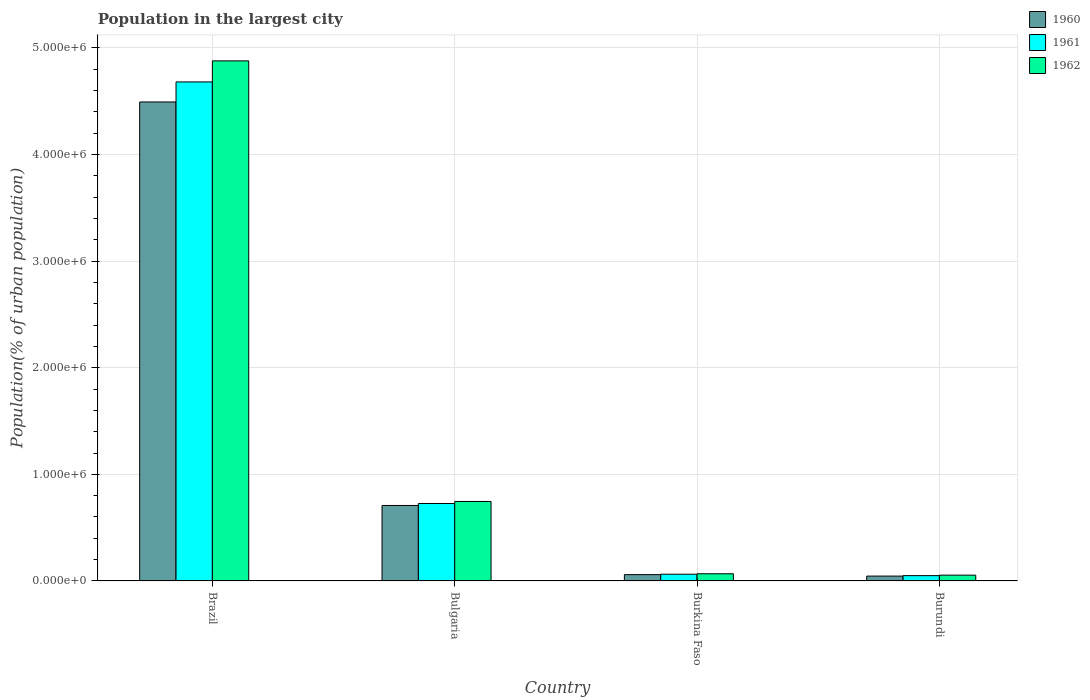How many different coloured bars are there?
Provide a short and direct response. 3. Are the number of bars per tick equal to the number of legend labels?
Your answer should be very brief. Yes. Are the number of bars on each tick of the X-axis equal?
Offer a terse response. Yes. How many bars are there on the 2nd tick from the left?
Offer a terse response. 3. What is the label of the 4th group of bars from the left?
Offer a very short reply. Burundi. What is the population in the largest city in 1960 in Brazil?
Provide a succinct answer. 4.49e+06. Across all countries, what is the maximum population in the largest city in 1961?
Provide a short and direct response. 4.68e+06. Across all countries, what is the minimum population in the largest city in 1962?
Offer a terse response. 5.44e+04. In which country was the population in the largest city in 1961 maximum?
Offer a terse response. Brazil. In which country was the population in the largest city in 1962 minimum?
Make the answer very short. Burundi. What is the total population in the largest city in 1960 in the graph?
Provide a succinct answer. 5.31e+06. What is the difference between the population in the largest city in 1962 in Bulgaria and that in Burundi?
Keep it short and to the point. 6.91e+05. What is the difference between the population in the largest city in 1960 in Burkina Faso and the population in the largest city in 1961 in Burundi?
Offer a very short reply. 9358. What is the average population in the largest city in 1960 per country?
Ensure brevity in your answer.  1.33e+06. What is the difference between the population in the largest city of/in 1962 and population in the largest city of/in 1961 in Burundi?
Provide a short and direct response. 4599. In how many countries, is the population in the largest city in 1960 greater than 600000 %?
Your answer should be very brief. 2. What is the ratio of the population in the largest city in 1961 in Brazil to that in Bulgaria?
Give a very brief answer. 6.44. Is the difference between the population in the largest city in 1962 in Brazil and Bulgaria greater than the difference between the population in the largest city in 1961 in Brazil and Bulgaria?
Keep it short and to the point. Yes. What is the difference between the highest and the second highest population in the largest city in 1961?
Your answer should be compact. -6.63e+05. What is the difference between the highest and the lowest population in the largest city in 1960?
Give a very brief answer. 4.45e+06. In how many countries, is the population in the largest city in 1961 greater than the average population in the largest city in 1961 taken over all countries?
Ensure brevity in your answer.  1. What does the 1st bar from the left in Brazil represents?
Your answer should be compact. 1960. How many bars are there?
Keep it short and to the point. 12. What is the difference between two consecutive major ticks on the Y-axis?
Give a very brief answer. 1.00e+06. Does the graph contain grids?
Your answer should be compact. Yes. How many legend labels are there?
Your answer should be compact. 3. What is the title of the graph?
Ensure brevity in your answer.  Population in the largest city. Does "1996" appear as one of the legend labels in the graph?
Ensure brevity in your answer.  No. What is the label or title of the X-axis?
Make the answer very short. Country. What is the label or title of the Y-axis?
Your response must be concise. Population(% of urban population). What is the Population(% of urban population) of 1960 in Brazil?
Offer a very short reply. 4.49e+06. What is the Population(% of urban population) of 1961 in Brazil?
Ensure brevity in your answer.  4.68e+06. What is the Population(% of urban population) in 1962 in Brazil?
Your response must be concise. 4.88e+06. What is the Population(% of urban population) of 1960 in Bulgaria?
Keep it short and to the point. 7.08e+05. What is the Population(% of urban population) in 1961 in Bulgaria?
Ensure brevity in your answer.  7.27e+05. What is the Population(% of urban population) of 1962 in Bulgaria?
Make the answer very short. 7.46e+05. What is the Population(% of urban population) in 1960 in Burkina Faso?
Provide a short and direct response. 5.91e+04. What is the Population(% of urban population) of 1961 in Burkina Faso?
Ensure brevity in your answer.  6.31e+04. What is the Population(% of urban population) in 1962 in Burkina Faso?
Your answer should be very brief. 6.73e+04. What is the Population(% of urban population) in 1960 in Burundi?
Make the answer very short. 4.56e+04. What is the Population(% of urban population) in 1961 in Burundi?
Offer a very short reply. 4.98e+04. What is the Population(% of urban population) of 1962 in Burundi?
Provide a short and direct response. 5.44e+04. Across all countries, what is the maximum Population(% of urban population) of 1960?
Ensure brevity in your answer.  4.49e+06. Across all countries, what is the maximum Population(% of urban population) in 1961?
Your answer should be compact. 4.68e+06. Across all countries, what is the maximum Population(% of urban population) of 1962?
Make the answer very short. 4.88e+06. Across all countries, what is the minimum Population(% of urban population) in 1960?
Keep it short and to the point. 4.56e+04. Across all countries, what is the minimum Population(% of urban population) in 1961?
Your answer should be compact. 4.98e+04. Across all countries, what is the minimum Population(% of urban population) in 1962?
Ensure brevity in your answer.  5.44e+04. What is the total Population(% of urban population) of 1960 in the graph?
Offer a terse response. 5.31e+06. What is the total Population(% of urban population) in 1961 in the graph?
Make the answer very short. 5.52e+06. What is the total Population(% of urban population) of 1962 in the graph?
Ensure brevity in your answer.  5.75e+06. What is the difference between the Population(% of urban population) in 1960 in Brazil and that in Bulgaria?
Your answer should be compact. 3.79e+06. What is the difference between the Population(% of urban population) in 1961 in Brazil and that in Bulgaria?
Give a very brief answer. 3.95e+06. What is the difference between the Population(% of urban population) in 1962 in Brazil and that in Bulgaria?
Provide a short and direct response. 4.13e+06. What is the difference between the Population(% of urban population) of 1960 in Brazil and that in Burkina Faso?
Your answer should be compact. 4.43e+06. What is the difference between the Population(% of urban population) of 1961 in Brazil and that in Burkina Faso?
Offer a very short reply. 4.62e+06. What is the difference between the Population(% of urban population) of 1962 in Brazil and that in Burkina Faso?
Your response must be concise. 4.81e+06. What is the difference between the Population(% of urban population) in 1960 in Brazil and that in Burundi?
Keep it short and to the point. 4.45e+06. What is the difference between the Population(% of urban population) of 1961 in Brazil and that in Burundi?
Ensure brevity in your answer.  4.63e+06. What is the difference between the Population(% of urban population) of 1962 in Brazil and that in Burundi?
Ensure brevity in your answer.  4.82e+06. What is the difference between the Population(% of urban population) of 1960 in Bulgaria and that in Burkina Faso?
Keep it short and to the point. 6.49e+05. What is the difference between the Population(% of urban population) of 1961 in Bulgaria and that in Burkina Faso?
Offer a terse response. 6.63e+05. What is the difference between the Population(% of urban population) in 1962 in Bulgaria and that in Burkina Faso?
Provide a short and direct response. 6.78e+05. What is the difference between the Population(% of urban population) of 1960 in Bulgaria and that in Burundi?
Your response must be concise. 6.62e+05. What is the difference between the Population(% of urban population) in 1961 in Bulgaria and that in Burundi?
Give a very brief answer. 6.77e+05. What is the difference between the Population(% of urban population) in 1962 in Bulgaria and that in Burundi?
Provide a short and direct response. 6.91e+05. What is the difference between the Population(% of urban population) in 1960 in Burkina Faso and that in Burundi?
Your answer should be very brief. 1.36e+04. What is the difference between the Population(% of urban population) of 1961 in Burkina Faso and that in Burundi?
Your answer should be compact. 1.33e+04. What is the difference between the Population(% of urban population) in 1962 in Burkina Faso and that in Burundi?
Offer a very short reply. 1.30e+04. What is the difference between the Population(% of urban population) in 1960 in Brazil and the Population(% of urban population) in 1961 in Bulgaria?
Keep it short and to the point. 3.77e+06. What is the difference between the Population(% of urban population) of 1960 in Brazil and the Population(% of urban population) of 1962 in Bulgaria?
Your response must be concise. 3.75e+06. What is the difference between the Population(% of urban population) of 1961 in Brazil and the Population(% of urban population) of 1962 in Bulgaria?
Your answer should be very brief. 3.94e+06. What is the difference between the Population(% of urban population) in 1960 in Brazil and the Population(% of urban population) in 1961 in Burkina Faso?
Make the answer very short. 4.43e+06. What is the difference between the Population(% of urban population) in 1960 in Brazil and the Population(% of urban population) in 1962 in Burkina Faso?
Your response must be concise. 4.43e+06. What is the difference between the Population(% of urban population) in 1961 in Brazil and the Population(% of urban population) in 1962 in Burkina Faso?
Offer a very short reply. 4.61e+06. What is the difference between the Population(% of urban population) of 1960 in Brazil and the Population(% of urban population) of 1961 in Burundi?
Your answer should be very brief. 4.44e+06. What is the difference between the Population(% of urban population) of 1960 in Brazil and the Population(% of urban population) of 1962 in Burundi?
Ensure brevity in your answer.  4.44e+06. What is the difference between the Population(% of urban population) of 1961 in Brazil and the Population(% of urban population) of 1962 in Burundi?
Offer a very short reply. 4.63e+06. What is the difference between the Population(% of urban population) of 1960 in Bulgaria and the Population(% of urban population) of 1961 in Burkina Faso?
Make the answer very short. 6.45e+05. What is the difference between the Population(% of urban population) in 1960 in Bulgaria and the Population(% of urban population) in 1962 in Burkina Faso?
Keep it short and to the point. 6.41e+05. What is the difference between the Population(% of urban population) of 1961 in Bulgaria and the Population(% of urban population) of 1962 in Burkina Faso?
Your response must be concise. 6.59e+05. What is the difference between the Population(% of urban population) of 1960 in Bulgaria and the Population(% of urban population) of 1961 in Burundi?
Your response must be concise. 6.58e+05. What is the difference between the Population(% of urban population) in 1960 in Bulgaria and the Population(% of urban population) in 1962 in Burundi?
Keep it short and to the point. 6.54e+05. What is the difference between the Population(% of urban population) of 1961 in Bulgaria and the Population(% of urban population) of 1962 in Burundi?
Your answer should be compact. 6.72e+05. What is the difference between the Population(% of urban population) of 1960 in Burkina Faso and the Population(% of urban population) of 1961 in Burundi?
Offer a very short reply. 9358. What is the difference between the Population(% of urban population) of 1960 in Burkina Faso and the Population(% of urban population) of 1962 in Burundi?
Provide a succinct answer. 4759. What is the difference between the Population(% of urban population) of 1961 in Burkina Faso and the Population(% of urban population) of 1962 in Burundi?
Ensure brevity in your answer.  8723. What is the average Population(% of urban population) in 1960 per country?
Your response must be concise. 1.33e+06. What is the average Population(% of urban population) in 1961 per country?
Offer a very short reply. 1.38e+06. What is the average Population(% of urban population) in 1962 per country?
Give a very brief answer. 1.44e+06. What is the difference between the Population(% of urban population) of 1960 and Population(% of urban population) of 1961 in Brazil?
Provide a succinct answer. -1.88e+05. What is the difference between the Population(% of urban population) in 1960 and Population(% of urban population) in 1962 in Brazil?
Ensure brevity in your answer.  -3.85e+05. What is the difference between the Population(% of urban population) of 1961 and Population(% of urban population) of 1962 in Brazil?
Offer a very short reply. -1.98e+05. What is the difference between the Population(% of urban population) of 1960 and Population(% of urban population) of 1961 in Bulgaria?
Provide a short and direct response. -1.85e+04. What is the difference between the Population(% of urban population) of 1960 and Population(% of urban population) of 1962 in Bulgaria?
Your answer should be very brief. -3.75e+04. What is the difference between the Population(% of urban population) in 1961 and Population(% of urban population) in 1962 in Bulgaria?
Provide a succinct answer. -1.90e+04. What is the difference between the Population(% of urban population) of 1960 and Population(% of urban population) of 1961 in Burkina Faso?
Keep it short and to the point. -3964. What is the difference between the Population(% of urban population) of 1960 and Population(% of urban population) of 1962 in Burkina Faso?
Offer a terse response. -8199. What is the difference between the Population(% of urban population) in 1961 and Population(% of urban population) in 1962 in Burkina Faso?
Provide a succinct answer. -4235. What is the difference between the Population(% of urban population) of 1960 and Population(% of urban population) of 1961 in Burundi?
Provide a succinct answer. -4204. What is the difference between the Population(% of urban population) of 1960 and Population(% of urban population) of 1962 in Burundi?
Provide a succinct answer. -8803. What is the difference between the Population(% of urban population) of 1961 and Population(% of urban population) of 1962 in Burundi?
Keep it short and to the point. -4599. What is the ratio of the Population(% of urban population) of 1960 in Brazil to that in Bulgaria?
Make the answer very short. 6.35. What is the ratio of the Population(% of urban population) of 1961 in Brazil to that in Bulgaria?
Offer a very short reply. 6.44. What is the ratio of the Population(% of urban population) in 1962 in Brazil to that in Bulgaria?
Your answer should be very brief. 6.54. What is the ratio of the Population(% of urban population) of 1960 in Brazil to that in Burkina Faso?
Your response must be concise. 75.99. What is the ratio of the Population(% of urban population) of 1961 in Brazil to that in Burkina Faso?
Offer a very short reply. 74.2. What is the ratio of the Population(% of urban population) of 1962 in Brazil to that in Burkina Faso?
Your response must be concise. 72.46. What is the ratio of the Population(% of urban population) of 1960 in Brazil to that in Burundi?
Your answer should be compact. 98.61. What is the ratio of the Population(% of urban population) of 1961 in Brazil to that in Burundi?
Your answer should be very brief. 94.06. What is the ratio of the Population(% of urban population) in 1962 in Brazil to that in Burundi?
Make the answer very short. 89.73. What is the ratio of the Population(% of urban population) of 1960 in Bulgaria to that in Burkina Faso?
Your answer should be compact. 11.98. What is the ratio of the Population(% of urban population) in 1961 in Bulgaria to that in Burkina Faso?
Give a very brief answer. 11.52. What is the ratio of the Population(% of urban population) in 1962 in Bulgaria to that in Burkina Faso?
Keep it short and to the point. 11.07. What is the ratio of the Population(% of urban population) of 1960 in Bulgaria to that in Burundi?
Offer a terse response. 15.54. What is the ratio of the Population(% of urban population) in 1961 in Bulgaria to that in Burundi?
Provide a short and direct response. 14.6. What is the ratio of the Population(% of urban population) in 1962 in Bulgaria to that in Burundi?
Make the answer very short. 13.71. What is the ratio of the Population(% of urban population) of 1960 in Burkina Faso to that in Burundi?
Provide a succinct answer. 1.3. What is the ratio of the Population(% of urban population) in 1961 in Burkina Faso to that in Burundi?
Your answer should be very brief. 1.27. What is the ratio of the Population(% of urban population) in 1962 in Burkina Faso to that in Burundi?
Offer a very short reply. 1.24. What is the difference between the highest and the second highest Population(% of urban population) of 1960?
Provide a short and direct response. 3.79e+06. What is the difference between the highest and the second highest Population(% of urban population) of 1961?
Make the answer very short. 3.95e+06. What is the difference between the highest and the second highest Population(% of urban population) of 1962?
Provide a succinct answer. 4.13e+06. What is the difference between the highest and the lowest Population(% of urban population) in 1960?
Give a very brief answer. 4.45e+06. What is the difference between the highest and the lowest Population(% of urban population) in 1961?
Ensure brevity in your answer.  4.63e+06. What is the difference between the highest and the lowest Population(% of urban population) of 1962?
Your answer should be very brief. 4.82e+06. 